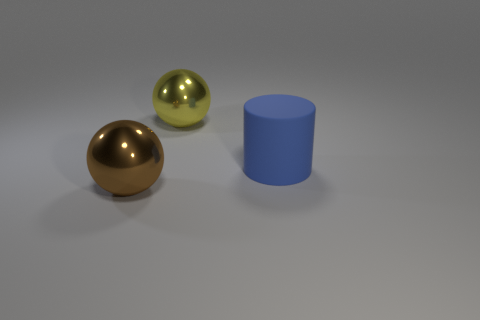Add 3 rubber objects. How many objects exist? 6 Subtract all cylinders. How many objects are left? 2 Subtract all small brown matte things. Subtract all large balls. How many objects are left? 1 Add 1 brown objects. How many brown objects are left? 2 Add 2 small green matte cylinders. How many small green matte cylinders exist? 2 Subtract 1 yellow balls. How many objects are left? 2 